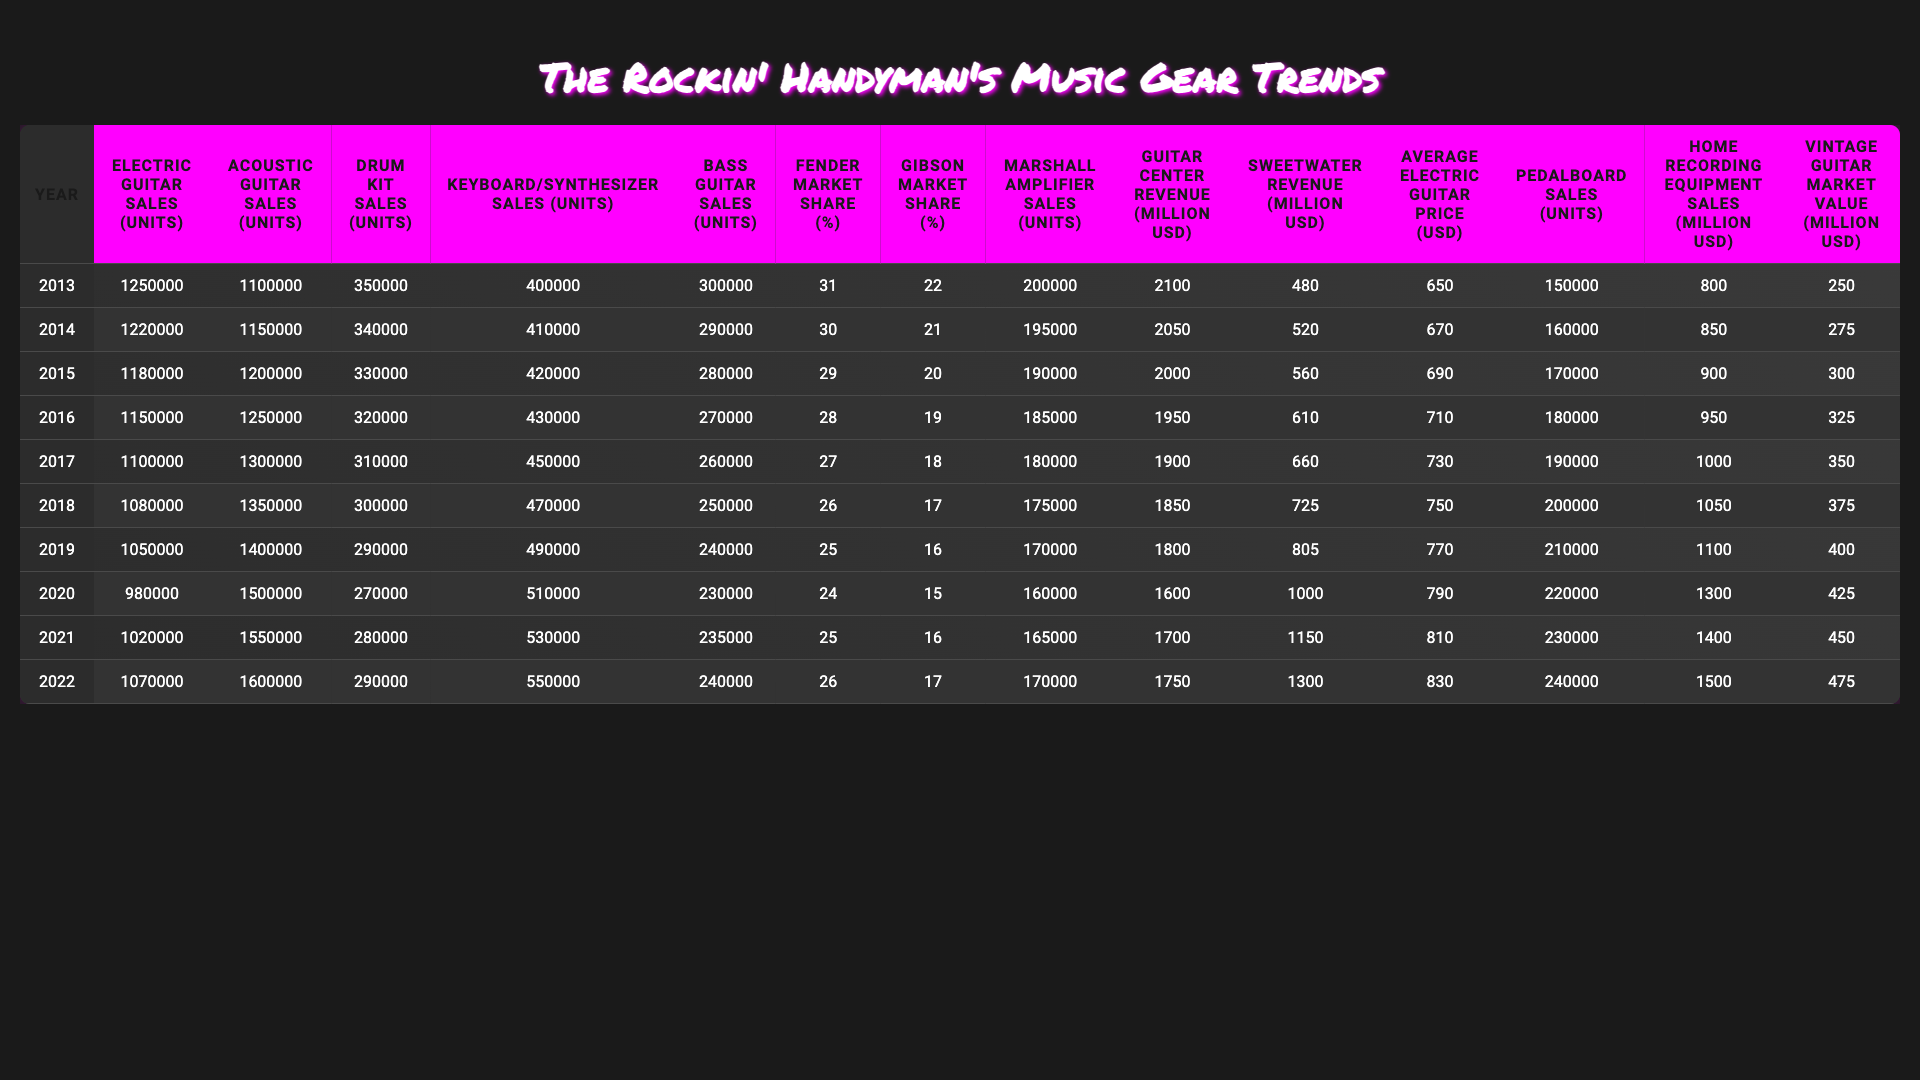What was the total number of Electric Guitars sold from 2013 to 2022? To find the total Electric Guitar sales, we add the units sold each year: 1250000 + 1220000 + 1180000 + 1150000 + 1100000 + 1080000 + 1050000 + 980000 + 1020000 + 1070000 = 11300000
Answer: 11300000 Which year had the highest sales of Acoustic Guitars? Looking at the data for Acoustic Guitar sales, the year with the highest sales was 2022 with 1600000 units sold, as it is the largest value in that column.
Answer: 2022 What was the percentage decrease in Drum Kit sales from 2013 to 2022? Drum Kit sales in 2013 were 350000 and in 2022 were 290000. To find the percentage decrease, we calculate: ((350000 - 290000) / 350000) * 100 = 17.14% decrease.
Answer: 17.14% What is the average sales of Bass Guitars over the past decade? The total sales of Bass Guitars over the ten years is 300000 + 290000 + 280000 + 270000 + 260000 + 250000 + 240000 + 230000 + 235000 + 240000 = 2550000. The average is 2550000 / 10 = 255000.
Answer: 255000 Did Fender's market share ever decrease during the decade? Yes, Fender's market share decreased from 31% in 2013 to 26% in 2022, confirming that it faced a decline over the years.
Answer: Yes In which year did Keyboard/Synthesizer sales first exceed 500,000 units? The sales of Keyboard/Synthesizers exceeded 500,000 units for the first time in the year 2020, where it reached 510,000 units.
Answer: 2020 What was the change in Guitar Center revenue from 2013 to 2022? Guitar Center revenue went from 2100 million USD in 2013 to 1750 million USD in 2022. The change is a decrease of 2100 - 1750 = 350 million USD.
Answer: -350 million USD Which type of musical equipment had the lowest sales in 2019? In 2019, the type of musical equipment with the lowest sales was the Drum Kits, with only 290,000 units sold compared to other types.
Answer: Drum Kits What is the trend observed in the sales of Pedalboards from 2013 to 2022? Pedalboard sales increased each year from 150,000 units in 2013 to 240,000 units in 2022, indicating a consistent upward trend in sales.
Answer: Increase What was the difference in sales between Electric Guitars and Acoustic Guitars in 2018? In 2018, Electric Guitars sold 1,080,000 units and Acoustic Guitars sold 1,350,000 units. The difference is 1,350,000 - 1,080,000 = 270,000 units.
Answer: 270,000 units 